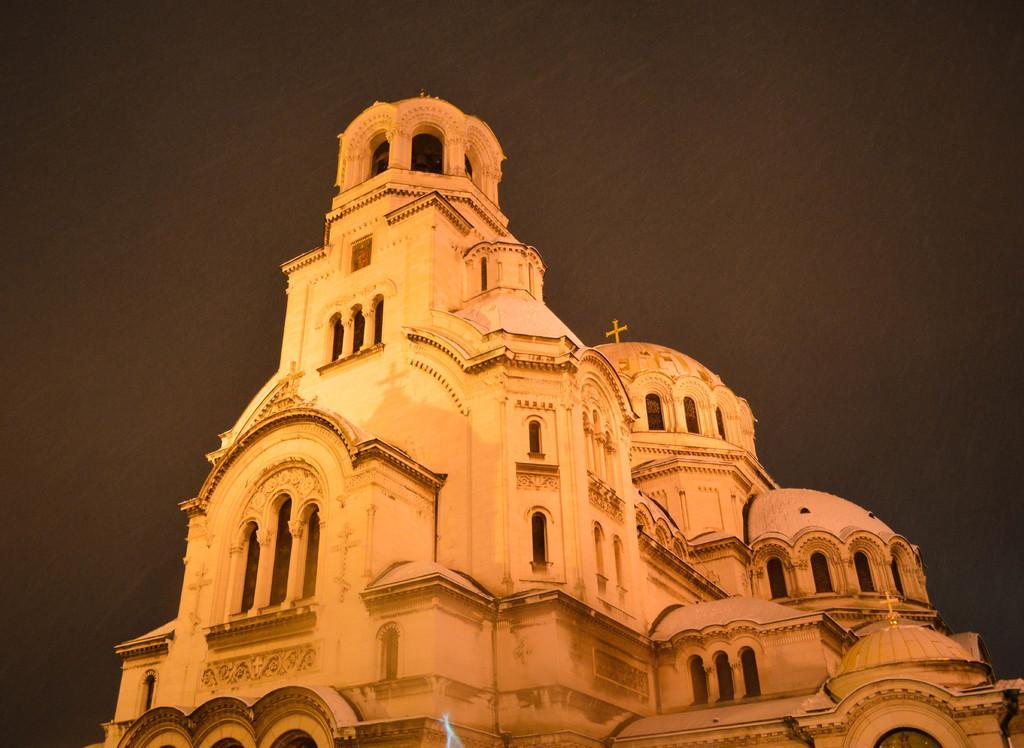How would you summarize this image in a sentence or two? In this image we can see a building, on the building, we can see a cross symbol, there are some windows and in the background, we can see the sky. 